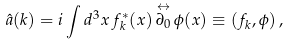<formula> <loc_0><loc_0><loc_500><loc_500>\hat { a } ( k ) = i \int d ^ { 3 } x \, f ^ { * } _ { k } ( x ) \, \overset { \leftrightarrow } { \partial _ { 0 } } \, \phi ( x ) \equiv ( f _ { k } , \phi ) \, ,</formula> 